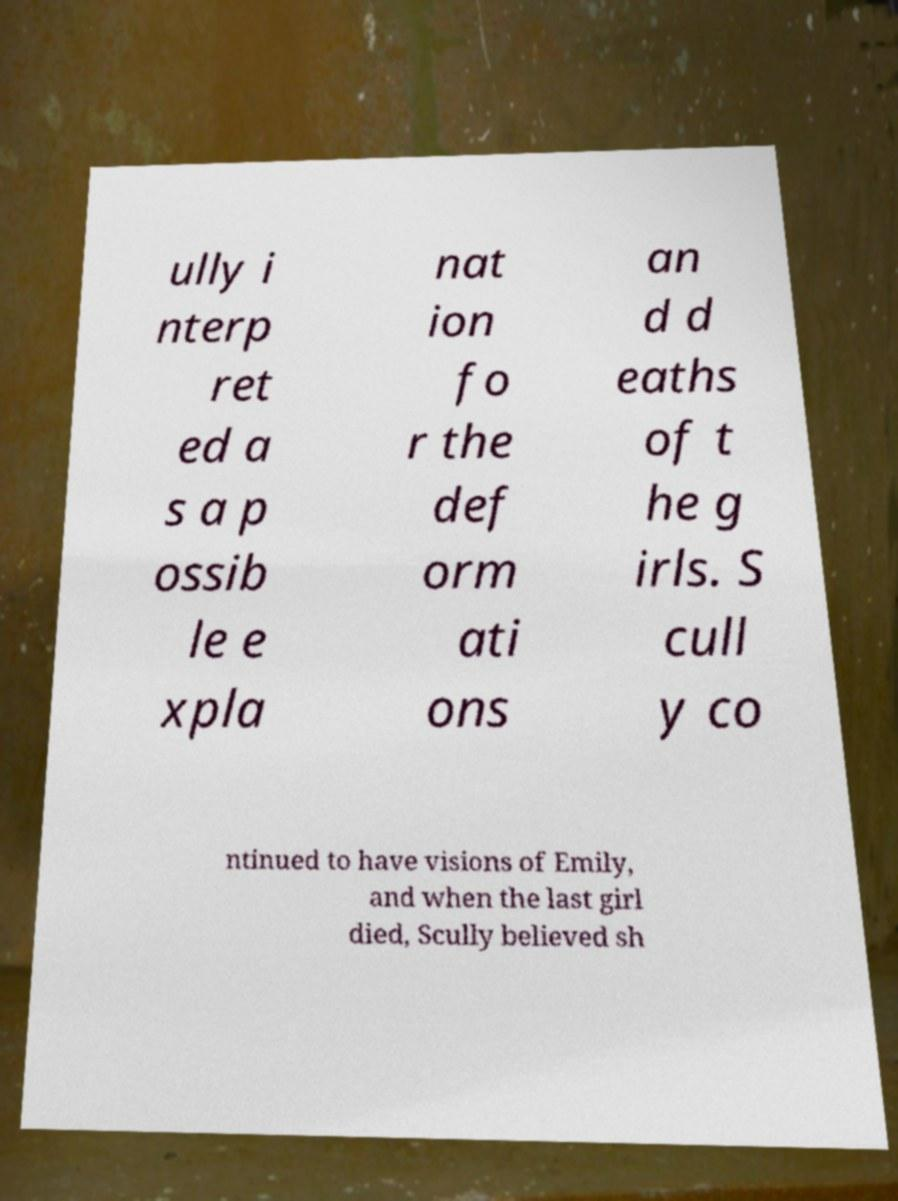Please identify and transcribe the text found in this image. ully i nterp ret ed a s a p ossib le e xpla nat ion fo r the def orm ati ons an d d eaths of t he g irls. S cull y co ntinued to have visions of Emily, and when the last girl died, Scully believed sh 